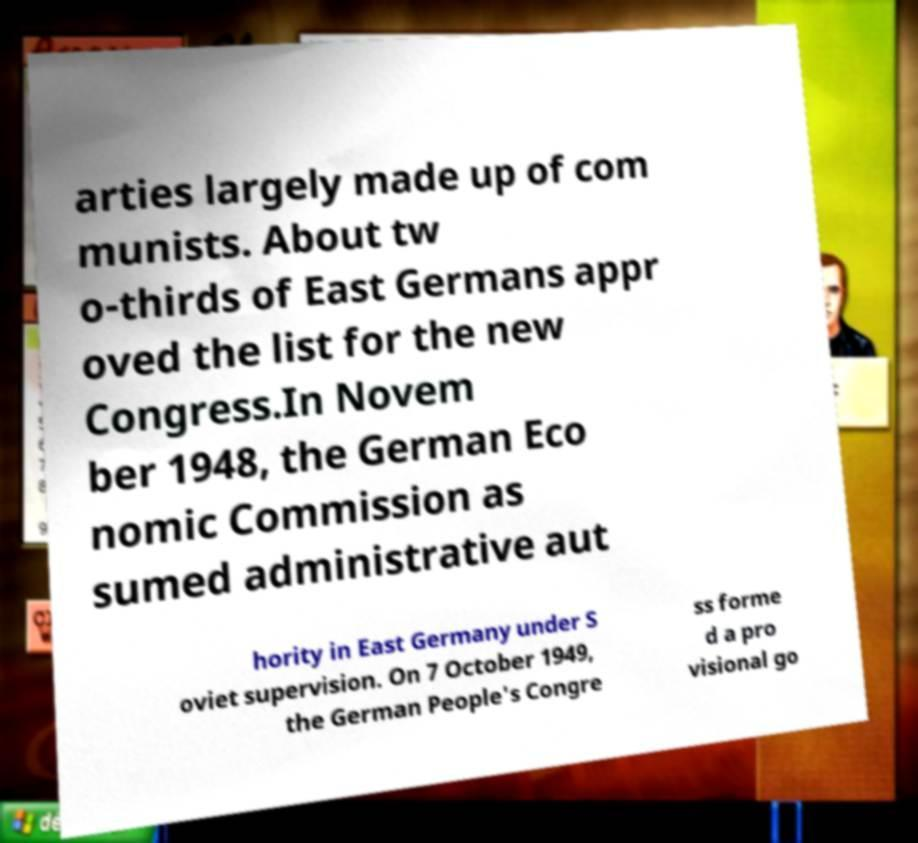Please read and relay the text visible in this image. What does it say? arties largely made up of com munists. About tw o-thirds of East Germans appr oved the list for the new Congress.In Novem ber 1948, the German Eco nomic Commission as sumed administrative aut hority in East Germany under S oviet supervision. On 7 October 1949, the German People's Congre ss forme d a pro visional go 